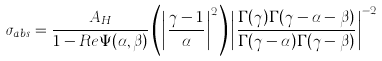<formula> <loc_0><loc_0><loc_500><loc_500>\sigma _ { a b s } = \frac { A _ { H } } { 1 - R e \Psi ( \alpha , \beta ) } \left ( \left | \frac { \gamma - 1 } { \alpha } \right | ^ { 2 } \right ) \left | \frac { \Gamma ( \gamma ) \Gamma ( \gamma - \alpha - \beta ) } { \Gamma ( \gamma - \alpha ) \Gamma ( \gamma - \beta ) } \right | ^ { - 2 }</formula> 